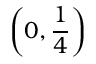Convert formula to latex. <formula><loc_0><loc_0><loc_500><loc_500>\left ( 0 , { \frac { 1 } { 4 } } \right )</formula> 